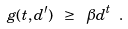Convert formula to latex. <formula><loc_0><loc_0><loc_500><loc_500>g ( t , d ^ { \prime } ) \ \geq \ \beta d ^ { t } \ .</formula> 